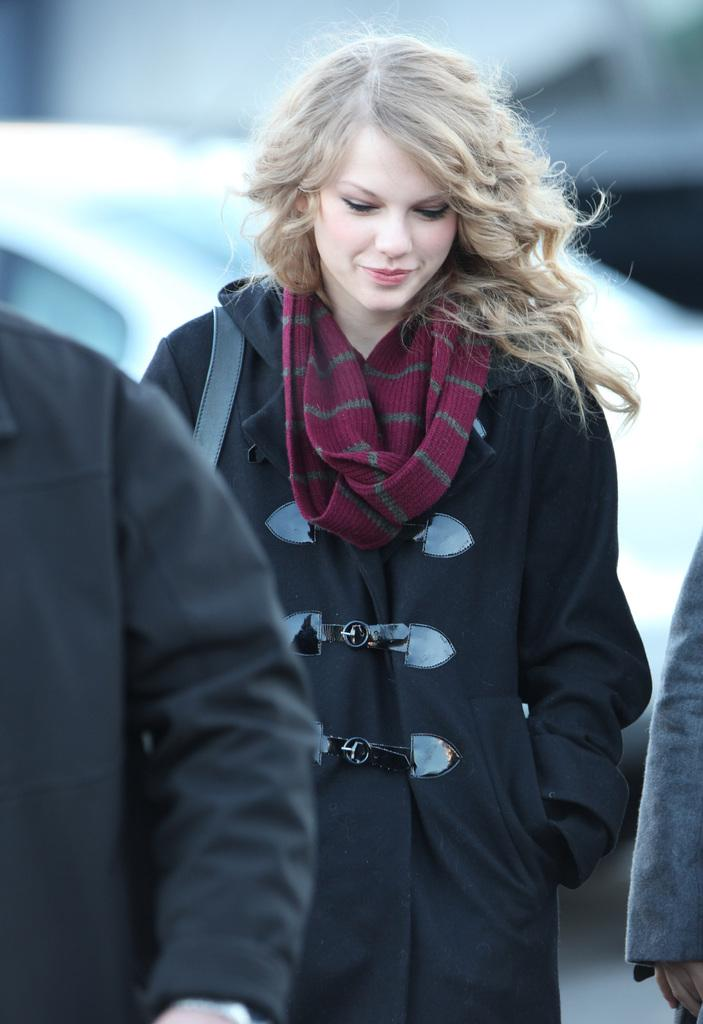What is the woman in the image doing? The woman is standing in the image. What expression does the woman have? The woman is smiling. Can you describe any body parts visible in the image? There are hands visible in the image. What can be seen in the background of the image? There is a car in the background of the image. What type of dress is the woman wearing under her clothes in the image? There is no information about the woman's dress or underwear in the image, as it only shows her standing and smiling. 